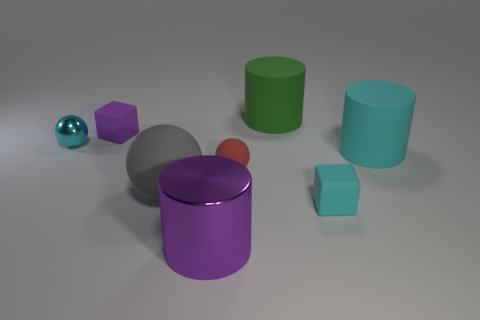Subtract 1 cylinders. How many cylinders are left? 2 Subtract all blocks. How many objects are left? 6 Add 8 cyan blocks. How many cyan blocks exist? 9 Subtract 0 red blocks. How many objects are left? 8 Subtract all matte cylinders. Subtract all gray balls. How many objects are left? 5 Add 8 cyan rubber things. How many cyan rubber things are left? 10 